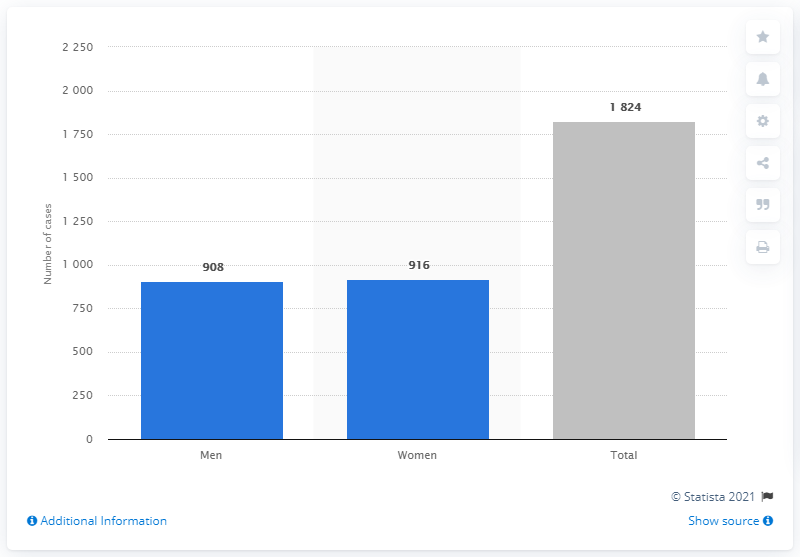Highlight a few significant elements in this photo. Nine hundred and eight individuals have been confirmed to have contracted COVID-19. 